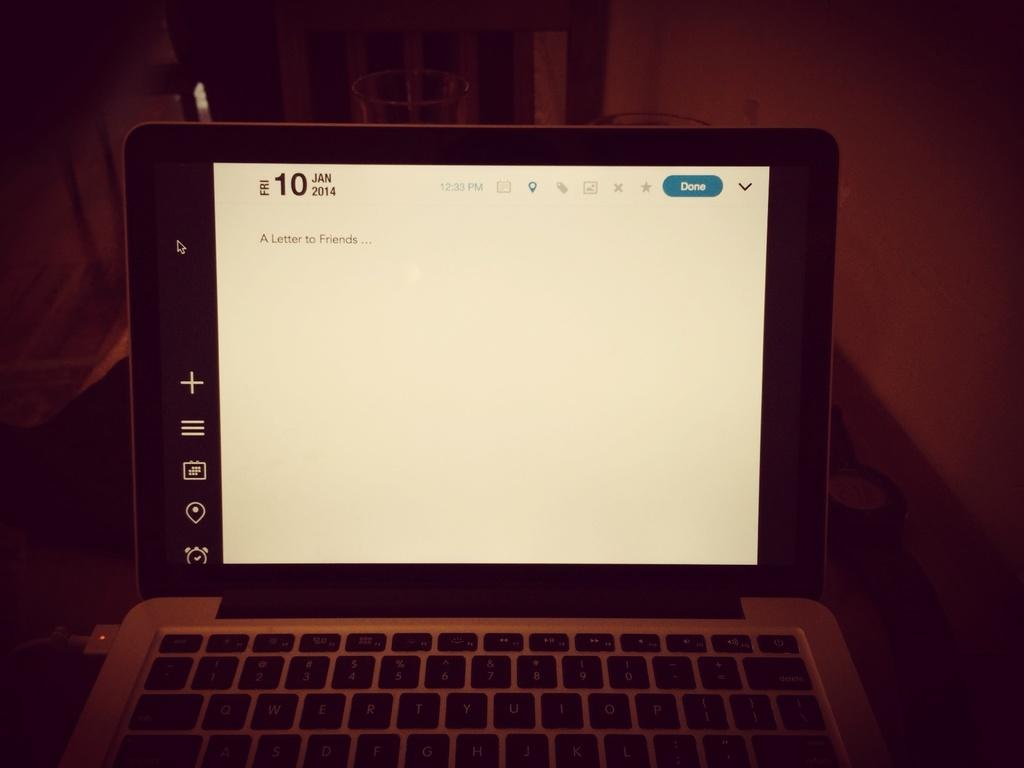What electronic device is present in the image? There is a laptop in the image. What is located on the right side of the image? There is a wall on the right side of the image. What can be seen in the background of the image? There are objects visible in the background of the image. How would you describe the lighting in the image? The background appears to be dark. What type of waste can be seen in the image? There is no waste present in the image. Can you describe the quince tree in the image? There is no quince tree present in the image. 